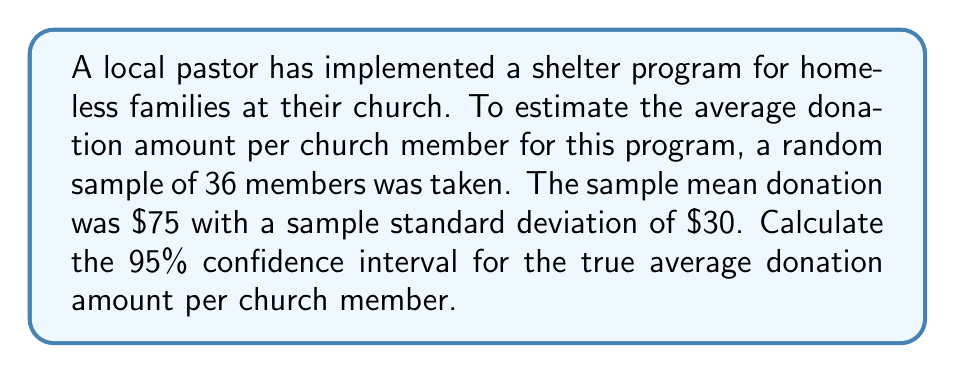Could you help me with this problem? To calculate the confidence interval, we'll follow these steps:

1) We're given:
   - Sample size (n) = 36
   - Sample mean (x̄) = $75
   - Sample standard deviation (s) = $30
   - Confidence level = 95%

2) For a 95% confidence interval with n < 30, we would use the t-distribution. However, since n ≥ 30, we can use the z-distribution.

3) The formula for the confidence interval is:

   $$ \text{CI} = \bar{x} \pm z_{\alpha/2} \cdot \frac{s}{\sqrt{n}} $$

   Where $z_{\alpha/2}$ is the critical value for the desired confidence level.

4) For a 95% confidence interval, $z_{\alpha/2} = 1.96$

5) Plugging in the values:

   $$ \text{CI} = 75 \pm 1.96 \cdot \frac{30}{\sqrt{36}} $$

6) Simplify:
   $$ \text{CI} = 75 \pm 1.96 \cdot \frac{30}{6} = 75 \pm 1.96 \cdot 5 = 75 \pm 9.8 $$

7) Therefore, the confidence interval is:

   $$ 75 - 9.8 \text{ to } 75 + 9.8 $$
   $$ 65.2 \text{ to } 84.8 $$
Answer: $65.20 to $84.80 